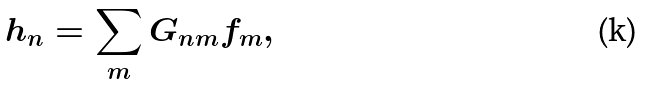Convert formula to latex. <formula><loc_0><loc_0><loc_500><loc_500>h _ { n } = \sum _ { m } G _ { n m } f _ { m } ,</formula> 